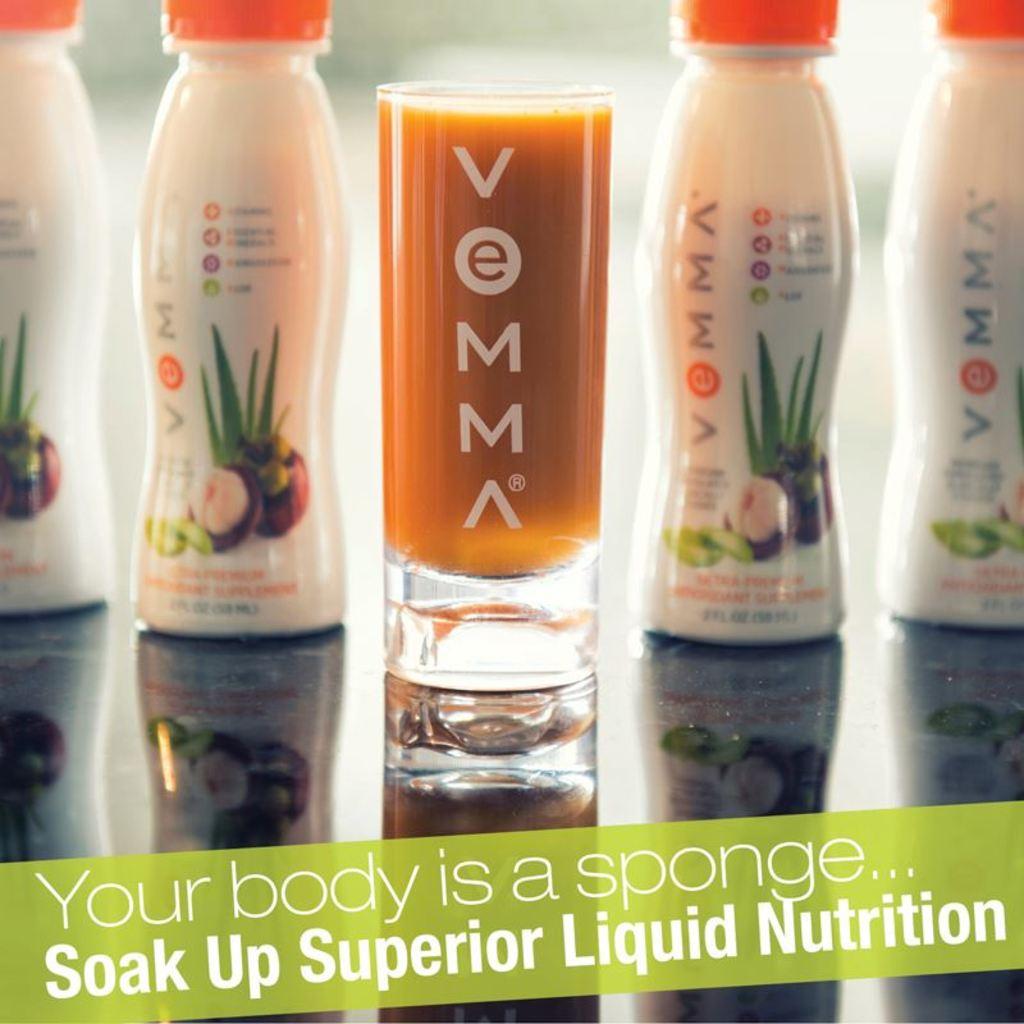What kind of nutrition does this brand offer?
Offer a terse response. Liquid. What is the brand name?
Make the answer very short. Vemma. 